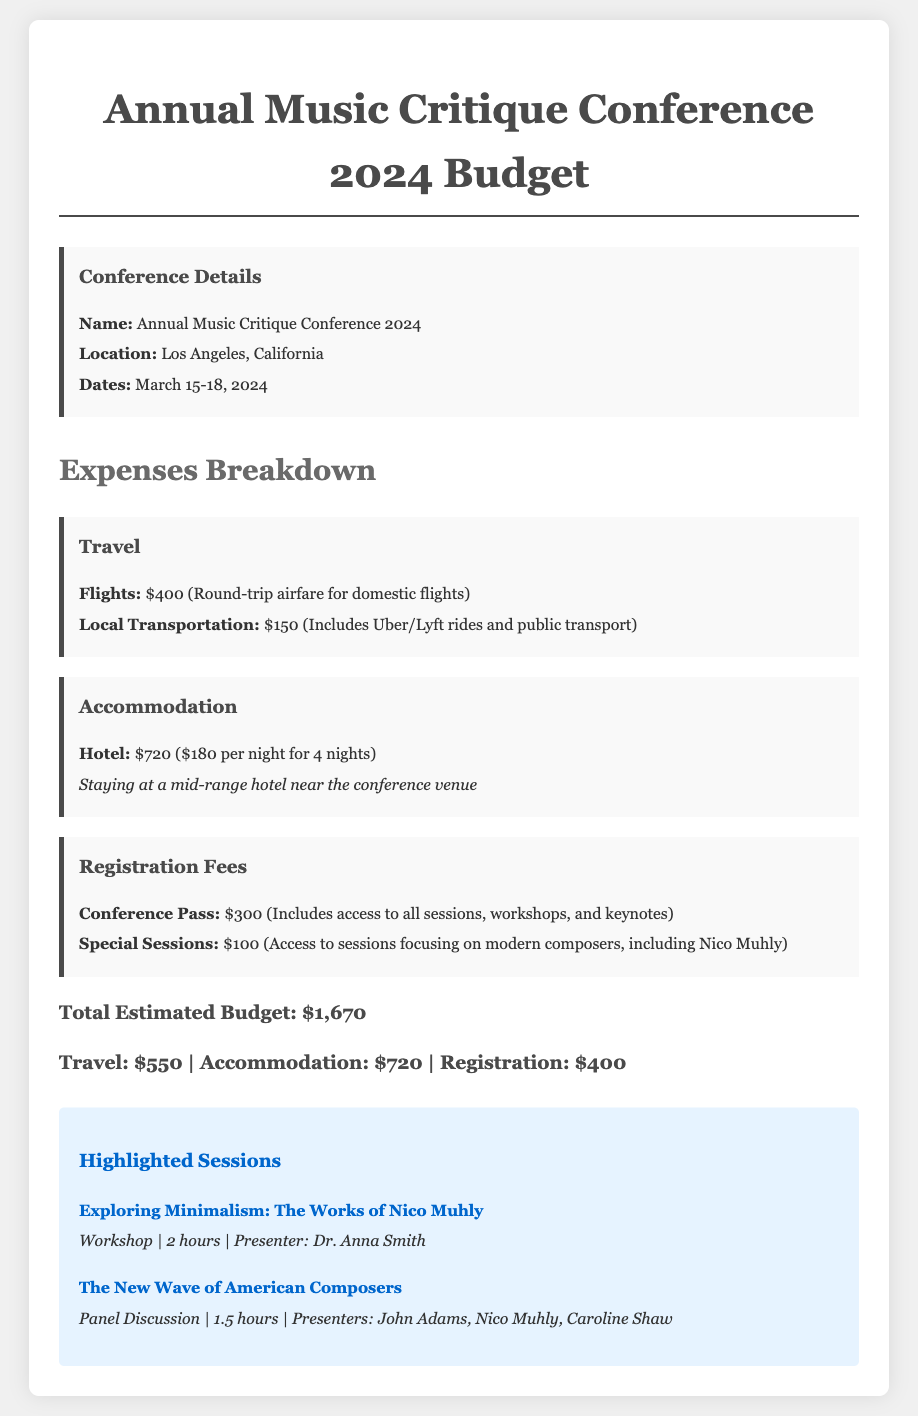What is the total estimated budget? The total estimated budget is provided at the end of the expenses breakdown, totaling $1,670.
Answer: $1,670 What are the dates of the conference? The dates of the conference are mentioned in the conference details section, which are March 15-18, 2024.
Answer: March 15-18, 2024 How much is the conference pass? The registration fees section specifies that the conference pass costs $300.
Answer: $300 What is the cost of local transportation? The travel section lists the local transportation cost as part of the total travel expenses, which is $150.
Answer: $150 Who is presenting the workshop on Nico Muhly's works? The highlighted sessions section mentions that Dr. Anna Smith is the presenter for the workshop titled "Exploring Minimalism: The Works of Nico Muhly."
Answer: Dr. Anna Smith How much is allocated for accommodation? The accommodation section details that the total cost for the hotel is $720.
Answer: $720 What kind of session is "The New Wave of American Composers"? The highlighted sessions section categorizes it as a panel discussion.
Answer: Panel Discussion What is the cost for special sessions focusing on modern composers? In the registration fees section, it specifies that access to special sessions costs an additional $100.
Answer: $100 What is the location of the conference? The conference details state that it takes place in Los Angeles, California.
Answer: Los Angeles, California 